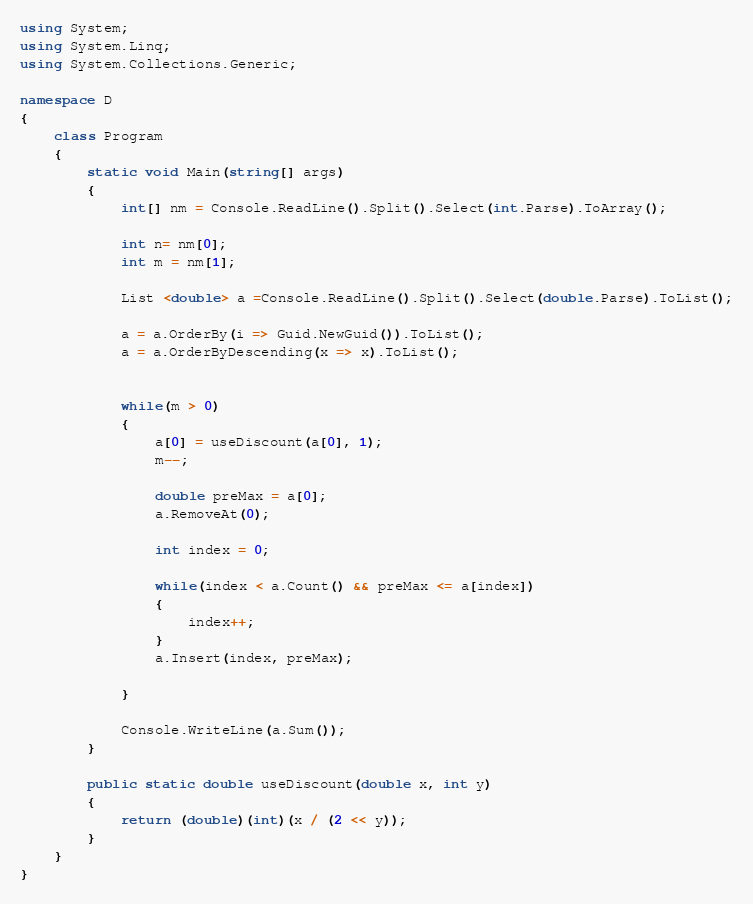Convert code to text. <code><loc_0><loc_0><loc_500><loc_500><_C#_>using System;
using System.Linq;
using System.Collections.Generic;

namespace D
{
    class Program
    {
        static void Main(string[] args)
        {
            int[] nm = Console.ReadLine().Split().Select(int.Parse).ToArray();

            int n= nm[0];
            int m = nm[1];
            
            List <double> a =Console.ReadLine().Split().Select(double.Parse).ToList();

            a = a.OrderBy(i => Guid.NewGuid()).ToList();
            a = a.OrderByDescending(x => x).ToList();


            while(m > 0)
            {
                a[0] = useDiscount(a[0], 1);
                m--;
                
                double preMax = a[0];
                a.RemoveAt(0);

                int index = 0;

                while(index < a.Count() && preMax <= a[index])
                {
                    index++;
                }
                a.Insert(index, preMax);

            }

            Console.WriteLine(a.Sum());
        }

        public static double useDiscount(double x, int y)
        {
            return (double)(int)(x / (2 << y));
        }
    }
}
</code> 